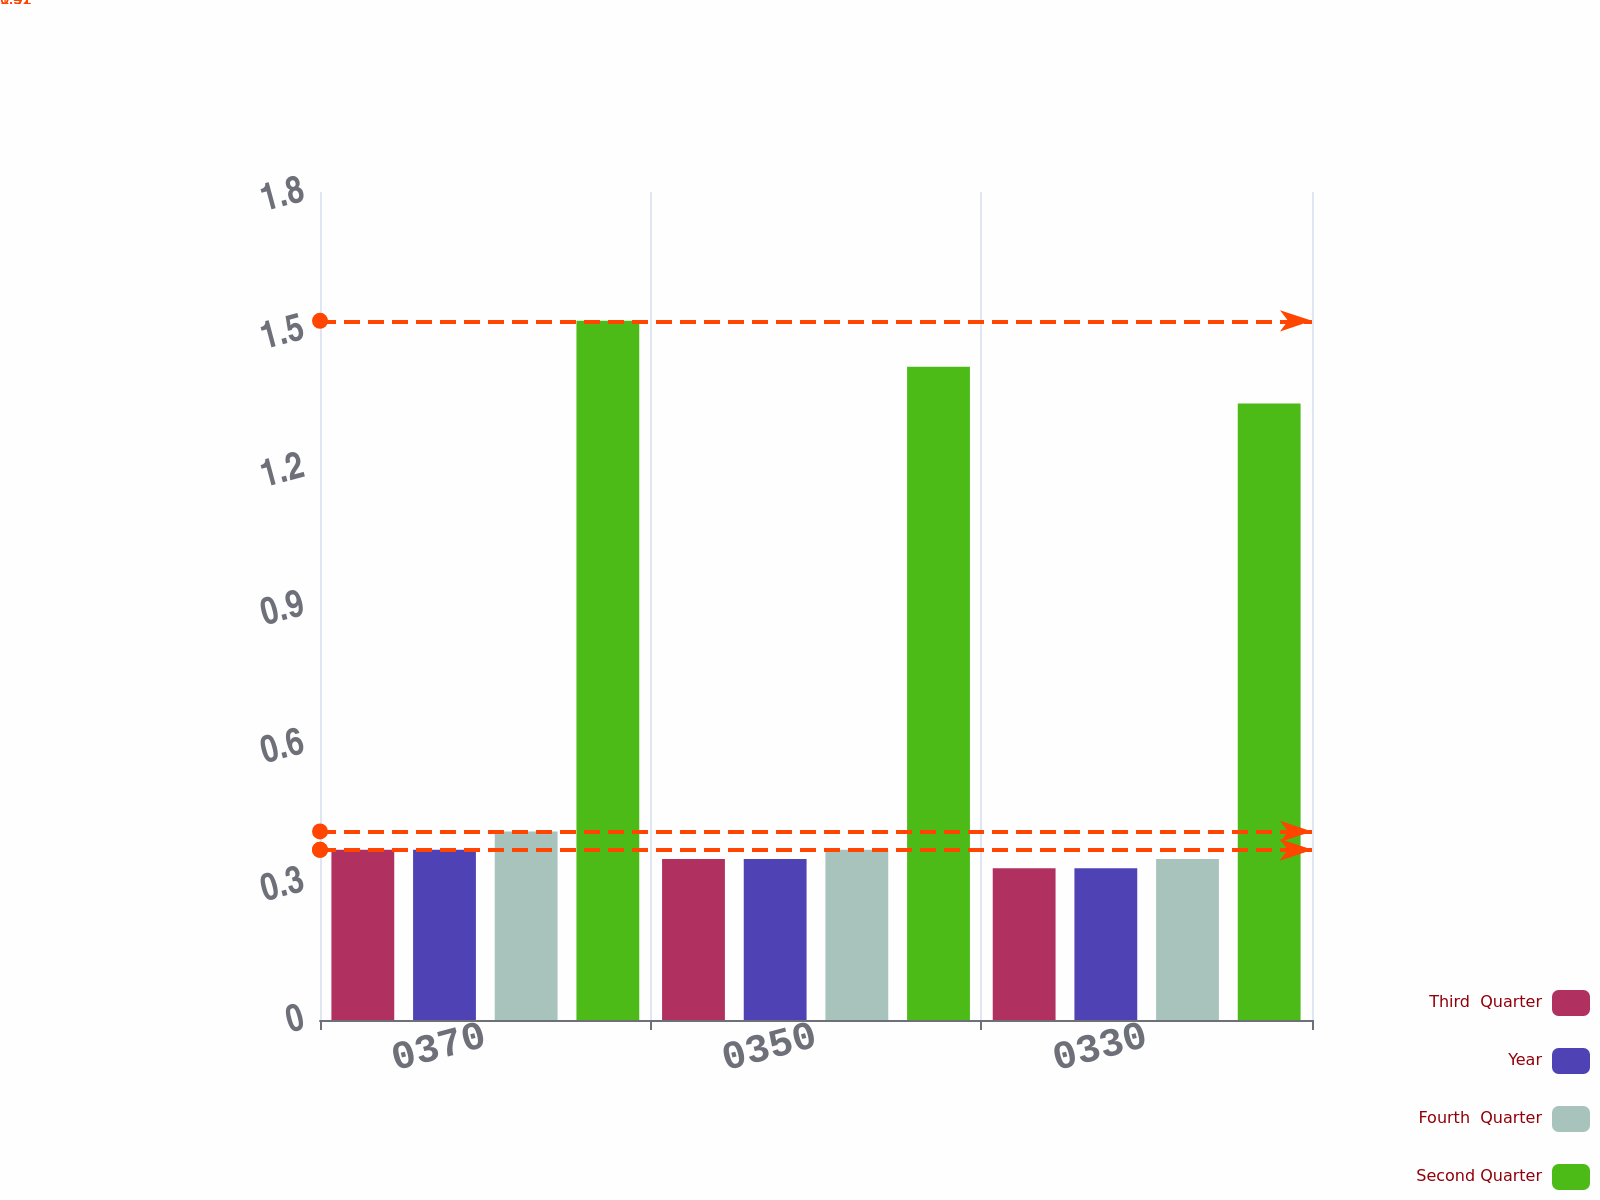Convert chart to OTSL. <chart><loc_0><loc_0><loc_500><loc_500><stacked_bar_chart><ecel><fcel>0370<fcel>0350<fcel>0330<nl><fcel>Third  Quarter<fcel>0.37<fcel>0.35<fcel>0.33<nl><fcel>Year<fcel>0.37<fcel>0.35<fcel>0.33<nl><fcel>Fourth  Quarter<fcel>0.41<fcel>0.37<fcel>0.35<nl><fcel>Second Quarter<fcel>1.52<fcel>1.42<fcel>1.34<nl></chart> 